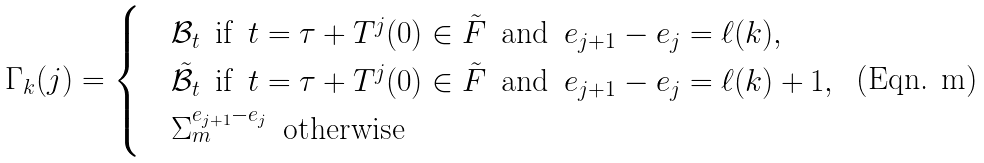Convert formula to latex. <formula><loc_0><loc_0><loc_500><loc_500>\Gamma _ { k } ( j ) = \begin{cases} & \mathcal { B } _ { t } \, \text { if } \, t = \tau + T ^ { j } ( 0 ) \in \tilde { F } \, \text { and } \, e _ { j + 1 } - e _ { j } = \ell ( k ) , \\ & \tilde { \mathcal { B } } _ { t } \, \text { if } \, t = \tau + T ^ { j } ( 0 ) \in \tilde { F } \, \text { and } \, e _ { j + 1 } - e _ { j } = \ell ( k ) + 1 , \\ & \Sigma _ { m } ^ { e _ { j + 1 } - e _ { j } } \, \text { otherwise} \end{cases}</formula> 